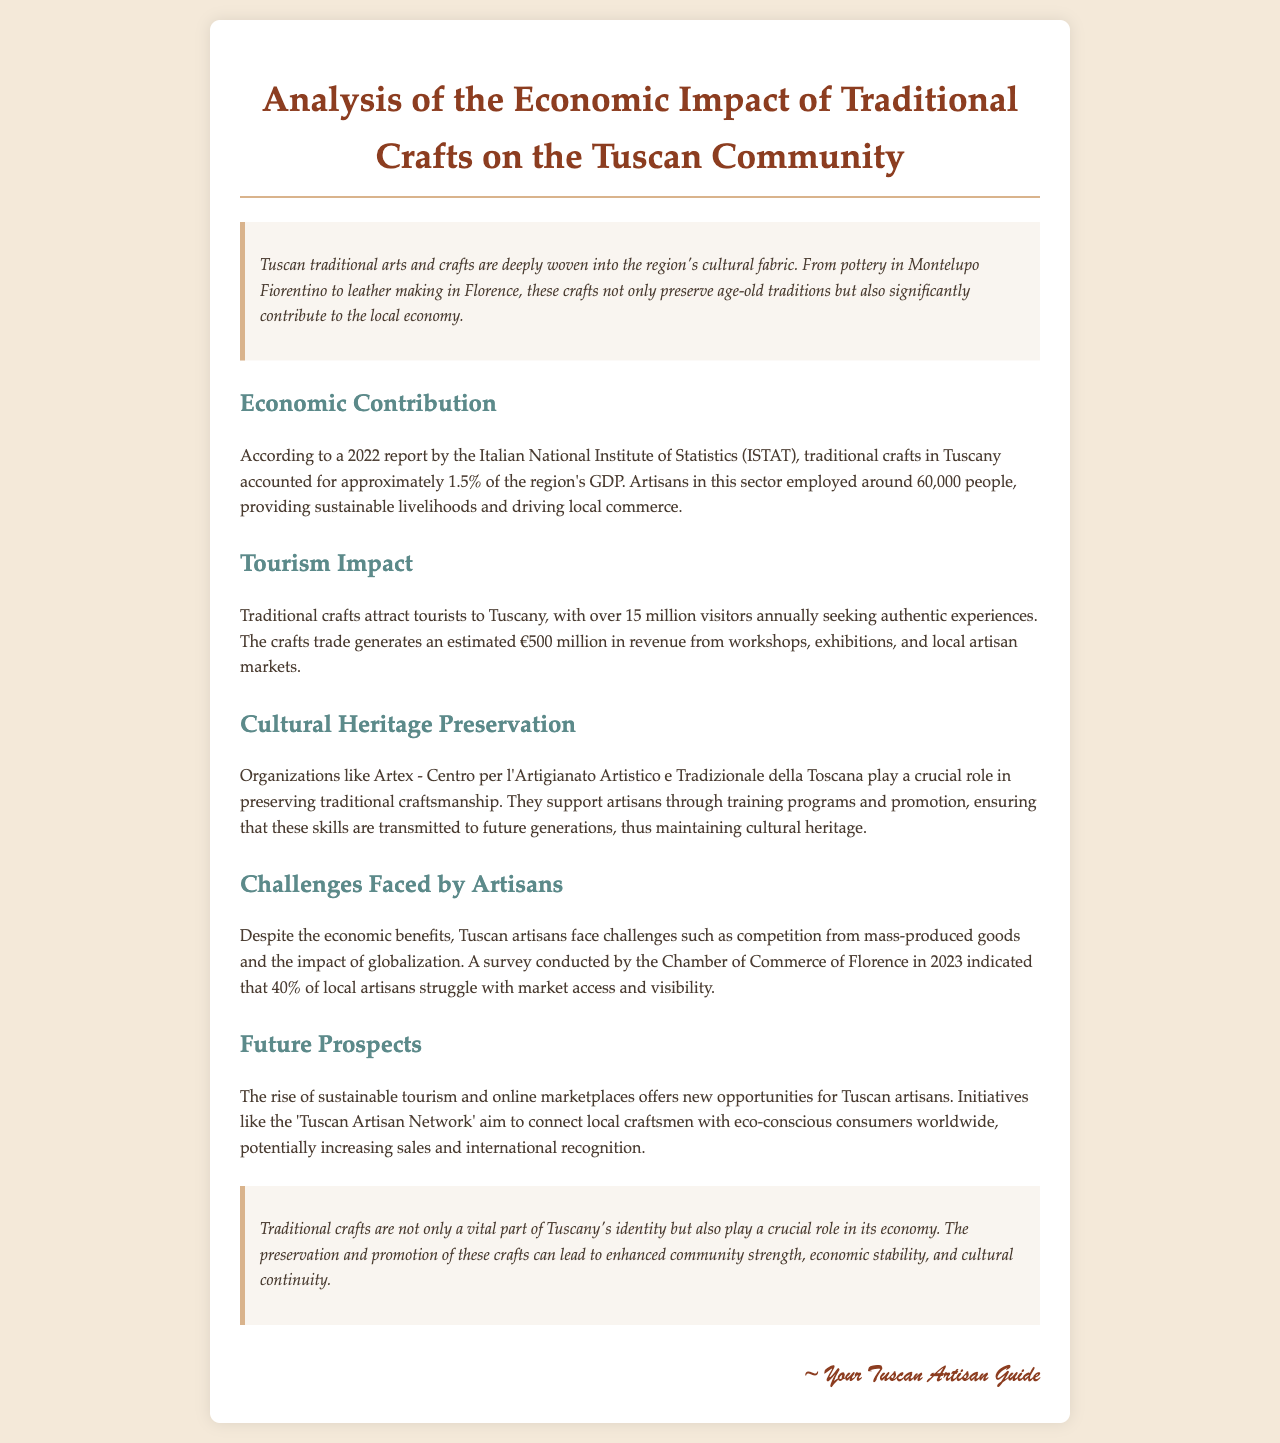What percentage of Tuscany's GDP is attributed to traditional crafts? According to the report, traditional crafts in Tuscany accounted for approximately 1.5% of the region's GDP.
Answer: 1.5% How many people are employed in the traditional crafts sector in Tuscany? The report states that artisans in this sector employed around 60,000 people.
Answer: 60,000 What is the estimated revenue generated from traditional crafts tourism? The document cites that the crafts trade generates an estimated €500 million in revenue.
Answer: €500 million Which organization supports the preservation of traditional craftsmanship in Tuscany? The report mentions Artex - Centro per l'Artigianato Artistico e Tradizionale della Toscana as a key organization.
Answer: Artex - Centro per l'Artigianato Artistico e Tradizionale della Toscana What percentage of artisans face challenges with market access? A survey indicated that 40% of local artisans struggle with market access and visibility.
Answer: 40% What new opportunities are mentioned for Tuscan artisans? The report discusses the rise of sustainable tourism and online marketplaces as new opportunities for artisans.
Answer: Sustainable tourism and online marketplaces What type of report is this document categorized as? The document is categorized as a report analyzing the economic impact of traditional crafts.
Answer: Analysis report What year did the survey regarding artisans’ challenges take place? The survey conducted by the Chamber of Commerce of Florence took place in 2023.
Answer: 2023 What is a key benefit of traditional crafts according to the conclusion? The conclusion states that traditional crafts play a crucial role in economic stability.
Answer: Economic stability 